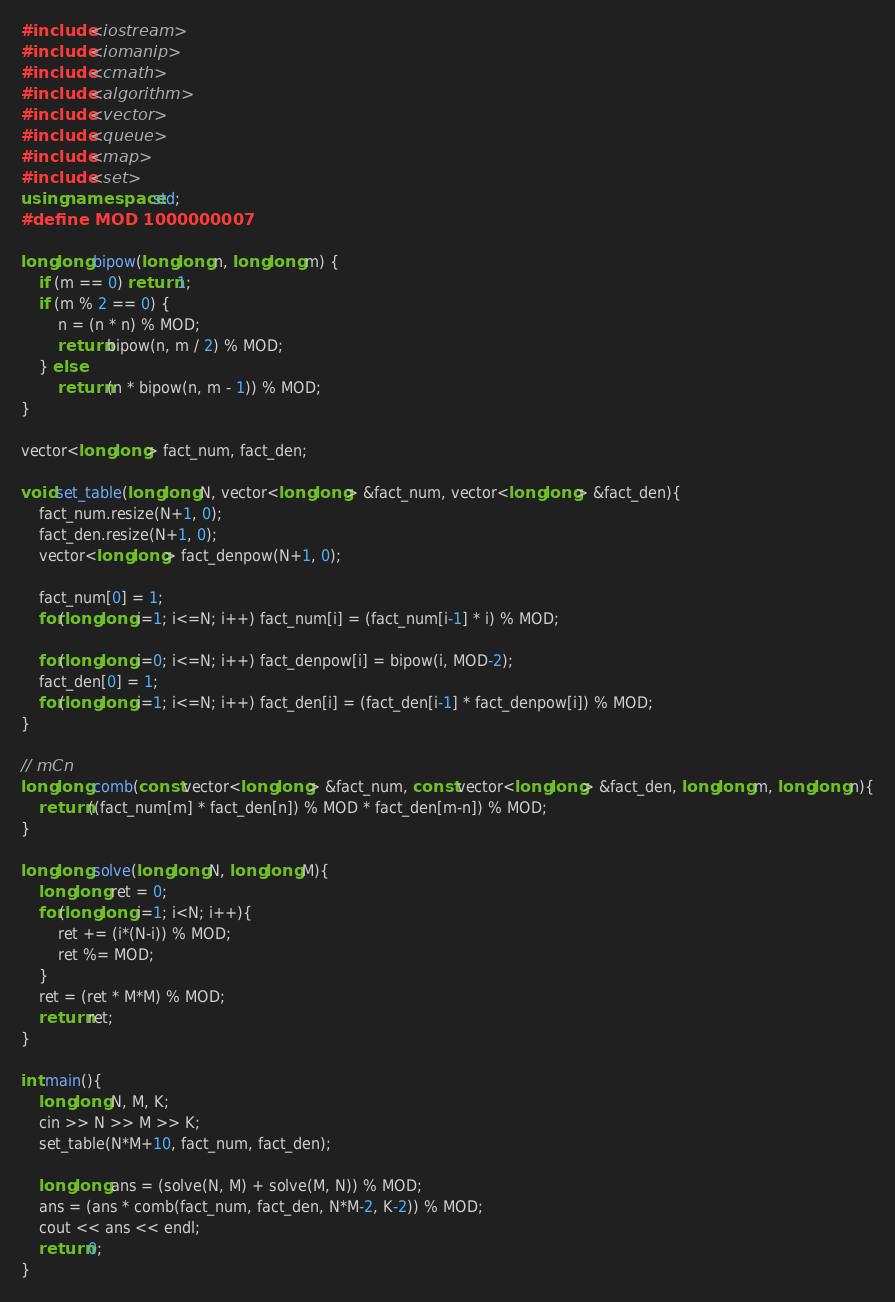<code> <loc_0><loc_0><loc_500><loc_500><_C++_>#include <iostream>
#include <iomanip>
#include <cmath>
#include <algorithm>
#include <vector>
#include <queue>
#include <map>
#include <set>
using namespace std;
#define MOD 1000000007

long long bipow(long long n, long long m) {
    if (m == 0) return 1;
    if (m % 2 == 0) {
        n = (n * n) % MOD;
        return bipow(n, m / 2) % MOD;
    } else
        return (n * bipow(n, m - 1)) % MOD;
}

vector<long long> fact_num, fact_den;

void set_table(long long N, vector<long long> &fact_num, vector<long long> &fact_den){
    fact_num.resize(N+1, 0);
    fact_den.resize(N+1, 0);
    vector<long long> fact_denpow(N+1, 0);

    fact_num[0] = 1;
    for(long long i=1; i<=N; i++) fact_num[i] = (fact_num[i-1] * i) % MOD;

    for(long long i=0; i<=N; i++) fact_denpow[i] = bipow(i, MOD-2);
    fact_den[0] = 1;
    for(long long i=1; i<=N; i++) fact_den[i] = (fact_den[i-1] * fact_denpow[i]) % MOD;
}

// mCn
long long comb(const vector<long long> &fact_num, const vector<long long> &fact_den, long long m, long long n){
    return ((fact_num[m] * fact_den[n]) % MOD * fact_den[m-n]) % MOD;
}

long long solve(long long N, long long M){
    long long ret = 0;
    for(long long i=1; i<N; i++){
        ret += (i*(N-i)) % MOD;
        ret %= MOD;
    }
    ret = (ret * M*M) % MOD;
    return ret;
}

int main(){
    long long N, M, K;
    cin >> N >> M >> K;
    set_table(N*M+10, fact_num, fact_den);

    long long ans = (solve(N, M) + solve(M, N)) % MOD;
    ans = (ans * comb(fact_num, fact_den, N*M-2, K-2)) % MOD;
    cout << ans << endl;
    return 0;
}</code> 